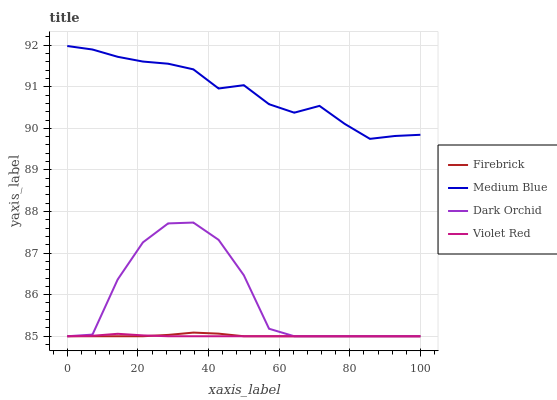Does Violet Red have the minimum area under the curve?
Answer yes or no. Yes. Does Medium Blue have the maximum area under the curve?
Answer yes or no. Yes. Does Medium Blue have the minimum area under the curve?
Answer yes or no. No. Does Violet Red have the maximum area under the curve?
Answer yes or no. No. Is Violet Red the smoothest?
Answer yes or no. Yes. Is Dark Orchid the roughest?
Answer yes or no. Yes. Is Medium Blue the smoothest?
Answer yes or no. No. Is Medium Blue the roughest?
Answer yes or no. No. Does Firebrick have the lowest value?
Answer yes or no. Yes. Does Medium Blue have the lowest value?
Answer yes or no. No. Does Medium Blue have the highest value?
Answer yes or no. Yes. Does Violet Red have the highest value?
Answer yes or no. No. Is Firebrick less than Medium Blue?
Answer yes or no. Yes. Is Medium Blue greater than Firebrick?
Answer yes or no. Yes. Does Dark Orchid intersect Firebrick?
Answer yes or no. Yes. Is Dark Orchid less than Firebrick?
Answer yes or no. No. Is Dark Orchid greater than Firebrick?
Answer yes or no. No. Does Firebrick intersect Medium Blue?
Answer yes or no. No. 